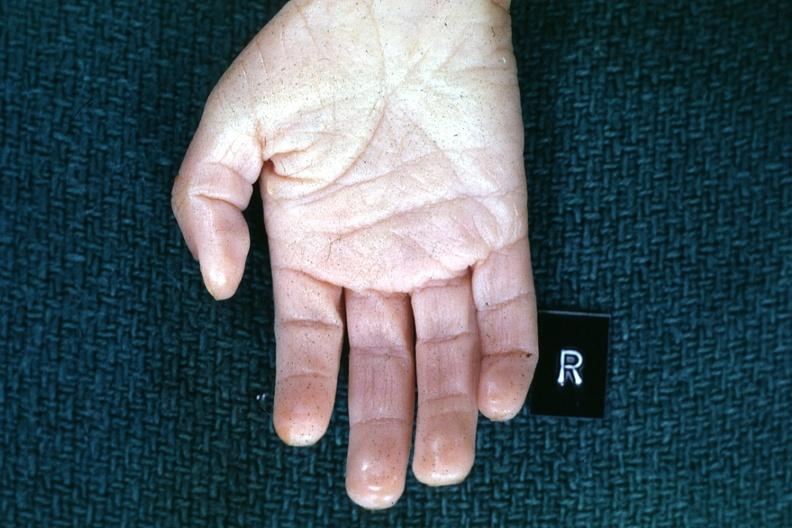what is present?
Answer the question using a single word or phrase. Normal palmar creases 